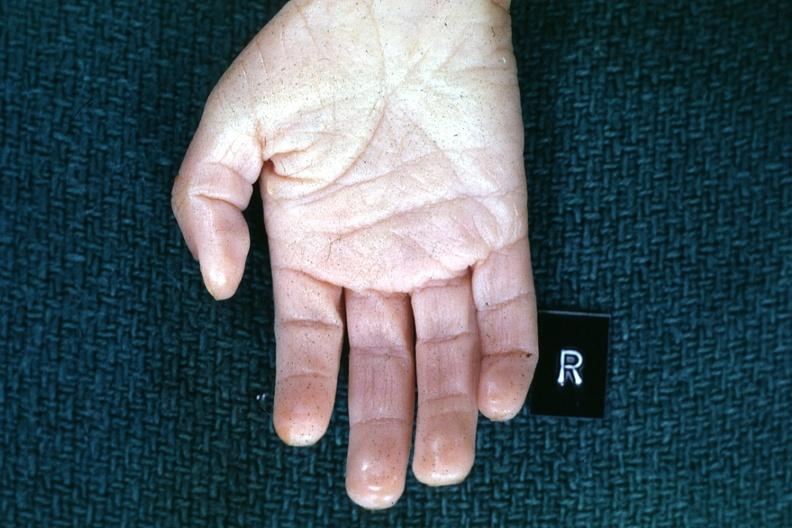what is present?
Answer the question using a single word or phrase. Normal palmar creases 